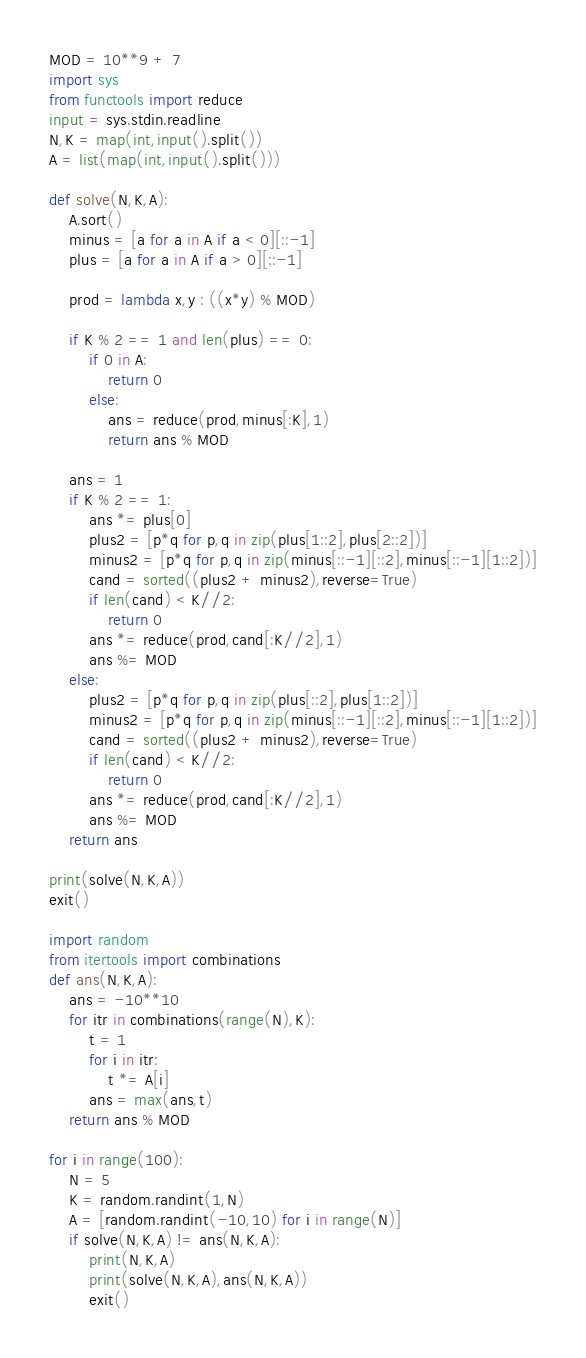<code> <loc_0><loc_0><loc_500><loc_500><_Python_>MOD = 10**9 + 7
import sys
from functools import reduce
input = sys.stdin.readline
N,K = map(int,input().split())
A = list(map(int,input().split()))

def solve(N,K,A):
    A.sort()
    minus = [a for a in A if a < 0][::-1]
    plus = [a for a in A if a > 0][::-1]

    prod = lambda x,y : ((x*y) % MOD)

    if K % 2 == 1 and len(plus) == 0:
        if 0 in A:
            return 0
        else:
            ans = reduce(prod,minus[:K],1)
            return ans % MOD

    ans = 1
    if K % 2 == 1:
        ans *= plus[0]
        plus2 = [p*q for p,q in zip(plus[1::2],plus[2::2])]
        minus2 = [p*q for p,q in zip(minus[::-1][::2],minus[::-1][1::2])]
        cand = sorted((plus2 + minus2),reverse=True)
        if len(cand) < K//2:
            return 0
        ans *= reduce(prod,cand[:K//2],1)
        ans %= MOD
    else:
        plus2 = [p*q for p,q in zip(plus[::2],plus[1::2])]
        minus2 = [p*q for p,q in zip(minus[::-1][::2],minus[::-1][1::2])]
        cand = sorted((plus2 + minus2),reverse=True)
        if len(cand) < K//2:
            return 0
        ans *= reduce(prod,cand[:K//2],1)
        ans %= MOD
    return ans

print(solve(N,K,A))
exit()

import random
from itertools import combinations
def ans(N,K,A):
    ans = -10**10
    for itr in combinations(range(N),K):
        t = 1
        for i in itr:
            t *= A[i]
        ans = max(ans,t)
    return ans % MOD

for i in range(100):
    N = 5 
    K = random.randint(1,N)
    A = [random.randint(-10,10) for i in range(N)]
    if solve(N,K,A) != ans(N,K,A):
        print(N,K,A)
        print(solve(N,K,A),ans(N,K,A))
        exit()

</code> 